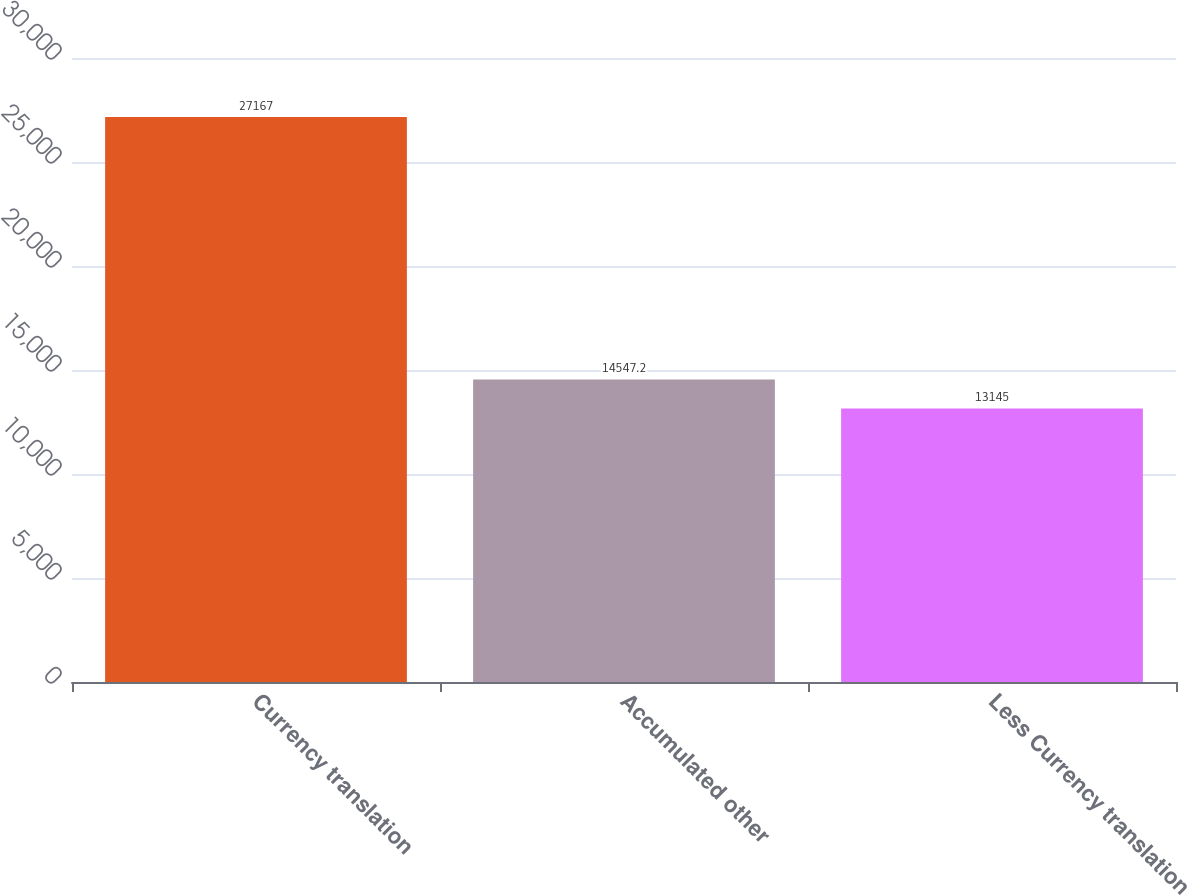Convert chart. <chart><loc_0><loc_0><loc_500><loc_500><bar_chart><fcel>Currency translation<fcel>Accumulated other<fcel>Less Currency translation<nl><fcel>27167<fcel>14547.2<fcel>13145<nl></chart> 